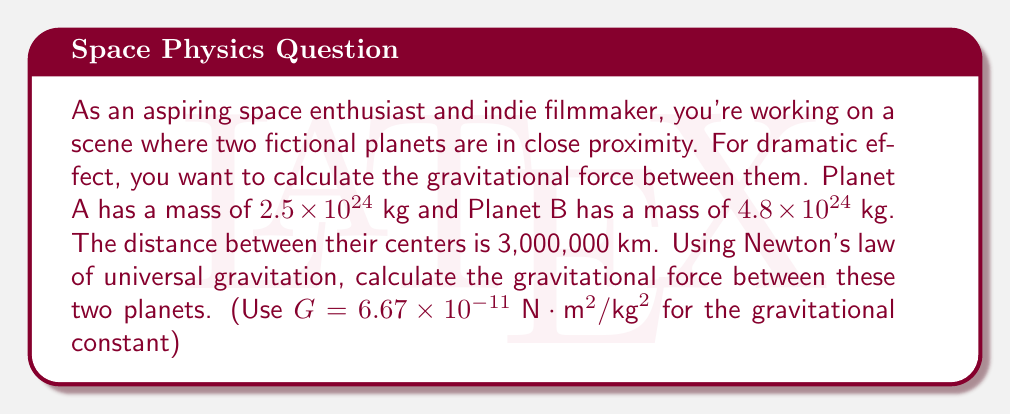What is the answer to this math problem? To solve this problem, we'll use Newton's law of universal gravitation:

$$F = G \frac{m_1 m_2}{r^2}$$

Where:
$F$ is the gravitational force between the two bodies
$G$ is the gravitational constant
$m_1$ and $m_2$ are the masses of the two bodies
$r$ is the distance between the centers of the two bodies

Let's plug in our values:

$G = 6.67 \times 10^{-11} \text{ N}\cdot\text{m}^2/\text{kg}^2$
$m_1 = 2.5 \times 10^{24} \text{ kg}$ (Planet A)
$m_2 = 4.8 \times 10^{24} \text{ kg}$ (Planet B)
$r = 3,000,000 \text{ km} = 3 \times 10^9 \text{ m}$

Now, let's calculate:

$$\begin{align}
F &= (6.67 \times 10^{-11}) \frac{(2.5 \times 10^{24})(4.8 \times 10^{24})}{(3 \times 10^9)^2} \\[10pt]
&= 6.67 \times 10^{-11} \cdot \frac{12 \times 10^{48}}{9 \times 10^{18}} \\[10pt]
&= 6.67 \times 10^{-11} \cdot (1.33 \times 10^{30}) \\[10pt]
&= 8.87 \times 10^{19} \text{ N}
\end{align}$$
Answer: The gravitational force between the two planets is approximately $8.87 \times 10^{19} \text{ N}$. 